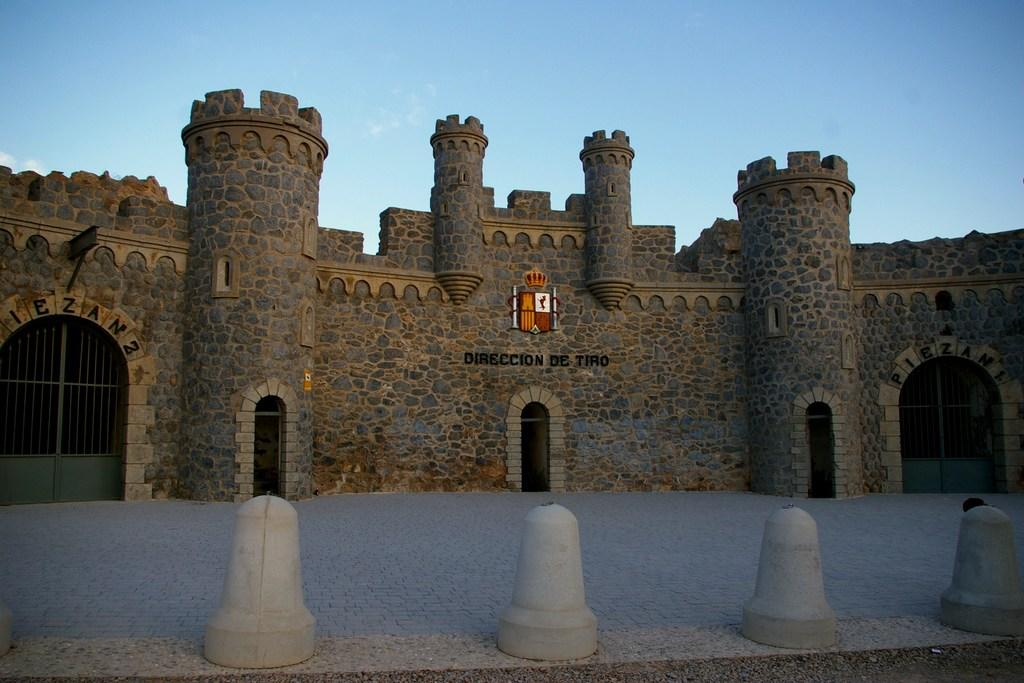What type of building is in the image? There is a stone building in the image. What features can be seen on the building? The building has windows. Is there any entrance or exit associated with the building? Yes, there is a gate associated with the building. What is visible at the top of the image? The sky is visible at the top of the image. What type of word can be seen written on the building in the image? There are no words visible on the building in the image. How many birds are perched on the roof of the building in the image? There are no birds present in the image. 